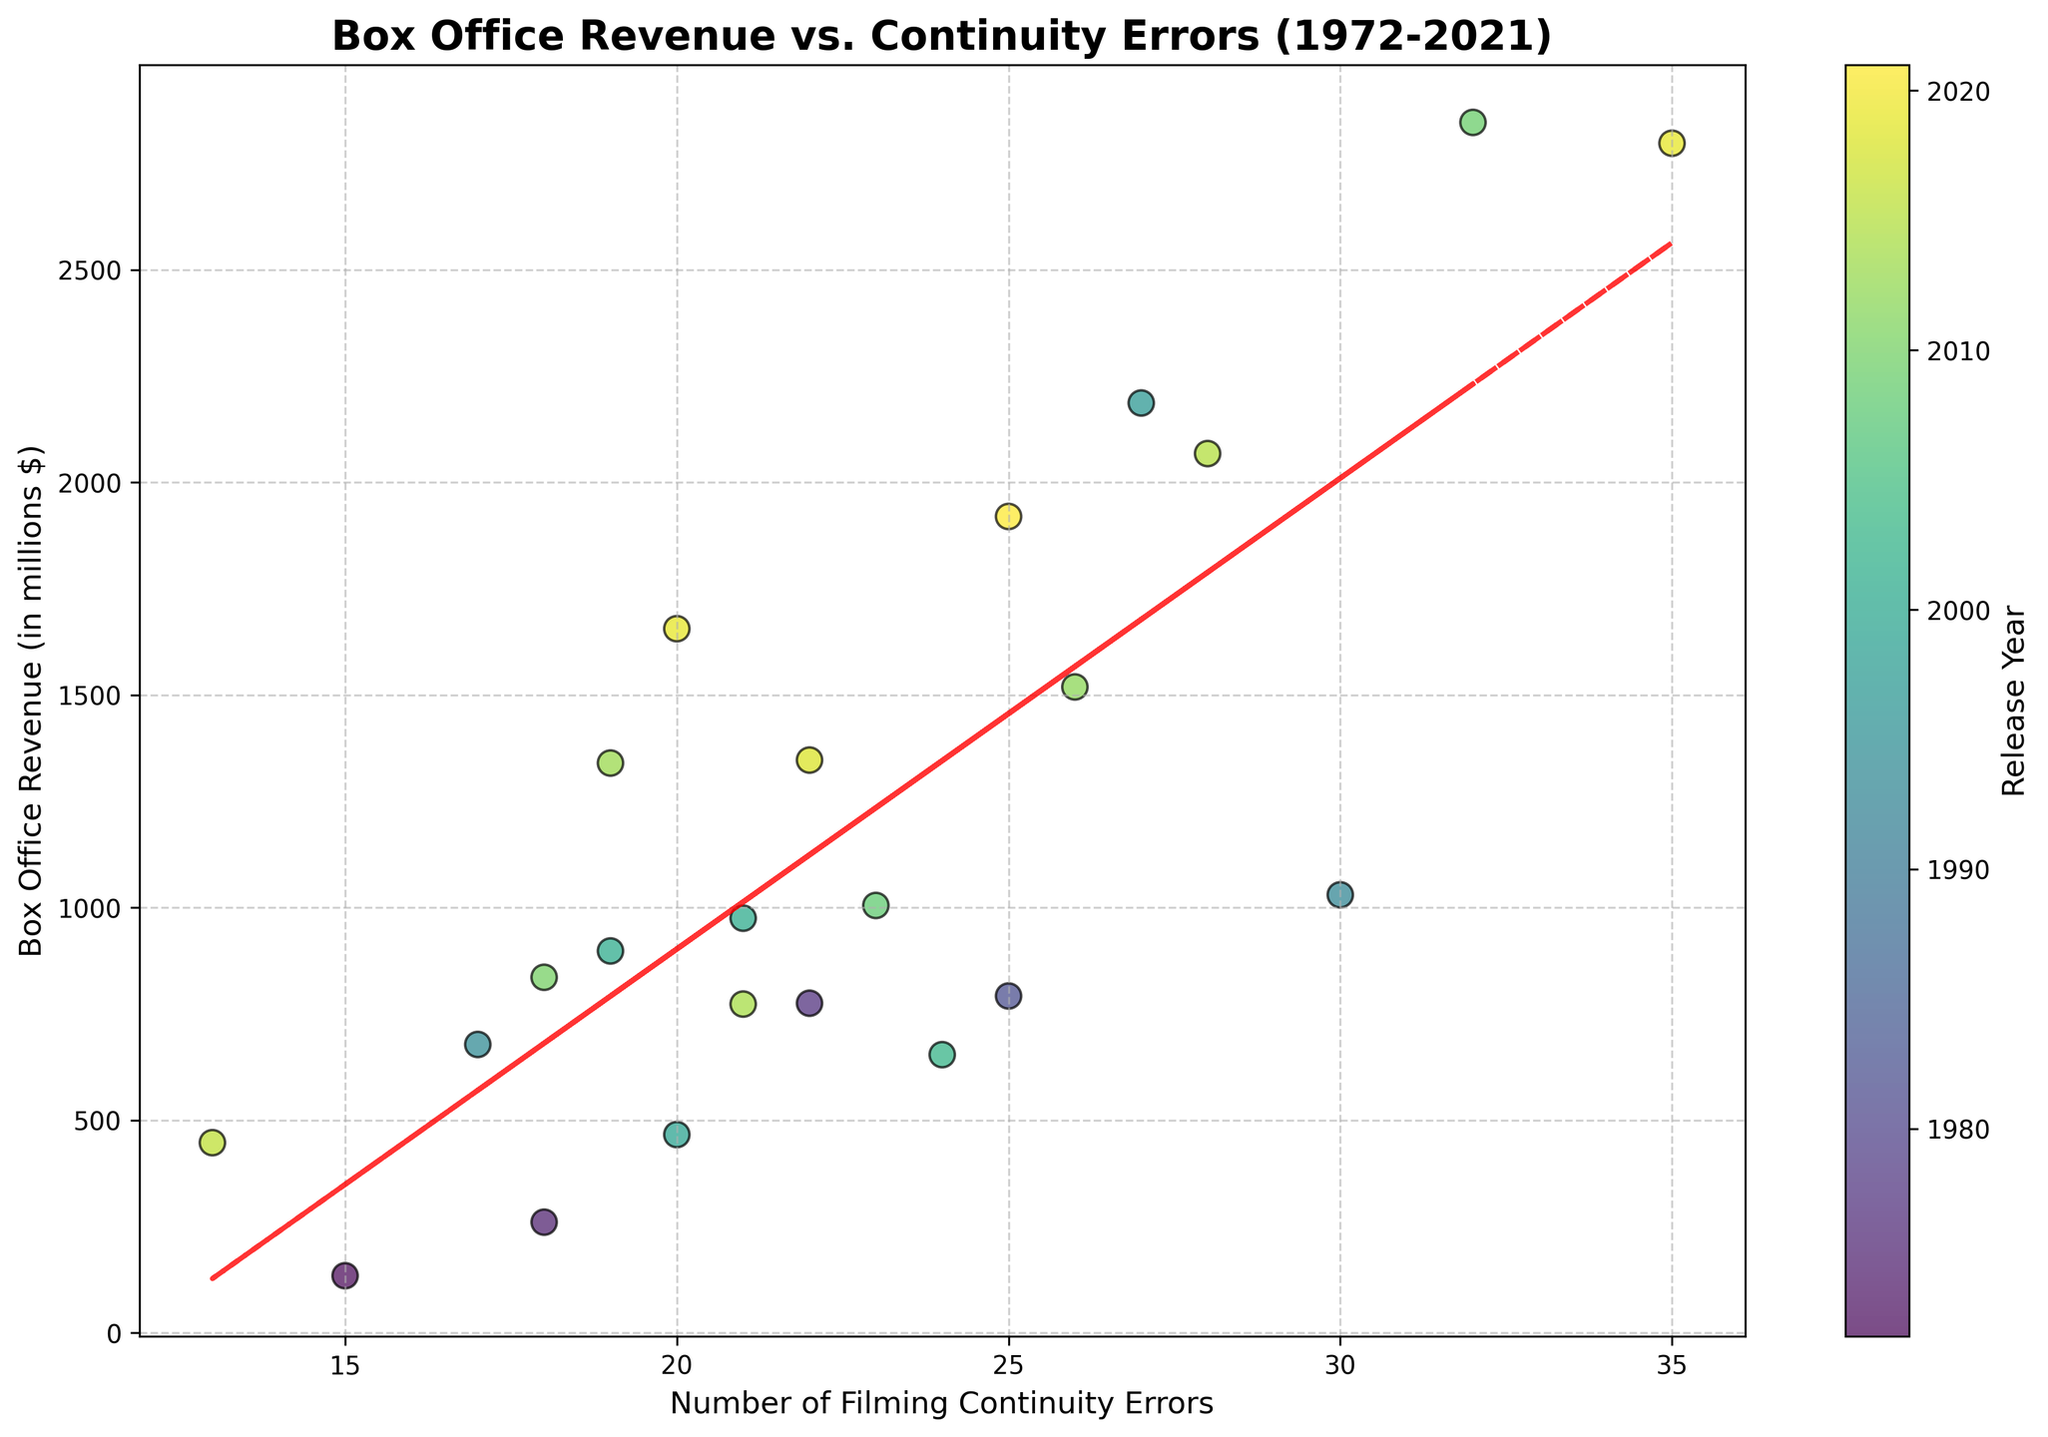What's the title of the figure? The title is at the top of the figure and summarizes the content of the plot.
Answer: Box Office Revenue vs. Continuity Errors (1972-2021) How many data points are present in the plot? Each data point represents one of the films listed, and you can count them directly from the scatter plot.
Answer: 23 What does the color of the data points represent? The color of the data points is mapped to the film's release year, as indicated by the color bar on the right side of the figure.
Answer: Release Year What's the box office revenue for the film with the fewest continuity errors? Identify the data point with the smallest 'Number of Filming Continuity Errors' on the x-axis and read its corresponding y-axis value.
Answer: $447 million (La La Land) Which film had the highest box office revenue, and how many continuity errors did it have? Find the highest point on the y-axis and check the corresponding x-axis value for the number of continuity errors. Cross-reference the data if needed.
Answer: Avatar, 32 errors How does the trend line in the plot relate to the data points? Observe the red dashed trend line against the scatter plot. A positive slope would indicate that as the number of continuity errors increases, the box office revenue generally increases as well.
Answer: Positive relationship What's the average box office revenue for films with more than 25 continuity errors? Identify all data points with x-values greater than 25, sum their y-values (box office revenue), and divide by the number of such films.
Answer: Average of $M Do newer films (darker-colored points) tend to have more continuity errors than older films? Compare the color intensity, which corresponds to the year, with the x-axis values across the scatter plot.
Answer: Yes, newer films generally have more errors Which film had higher revenue: the one released in 1997 or the one released in 2012? Locate the data points based on their release years. The color bar and plot labels aid this identification. Compare their y-axis values for revenue.
Answer: 1997 (Titanic) 